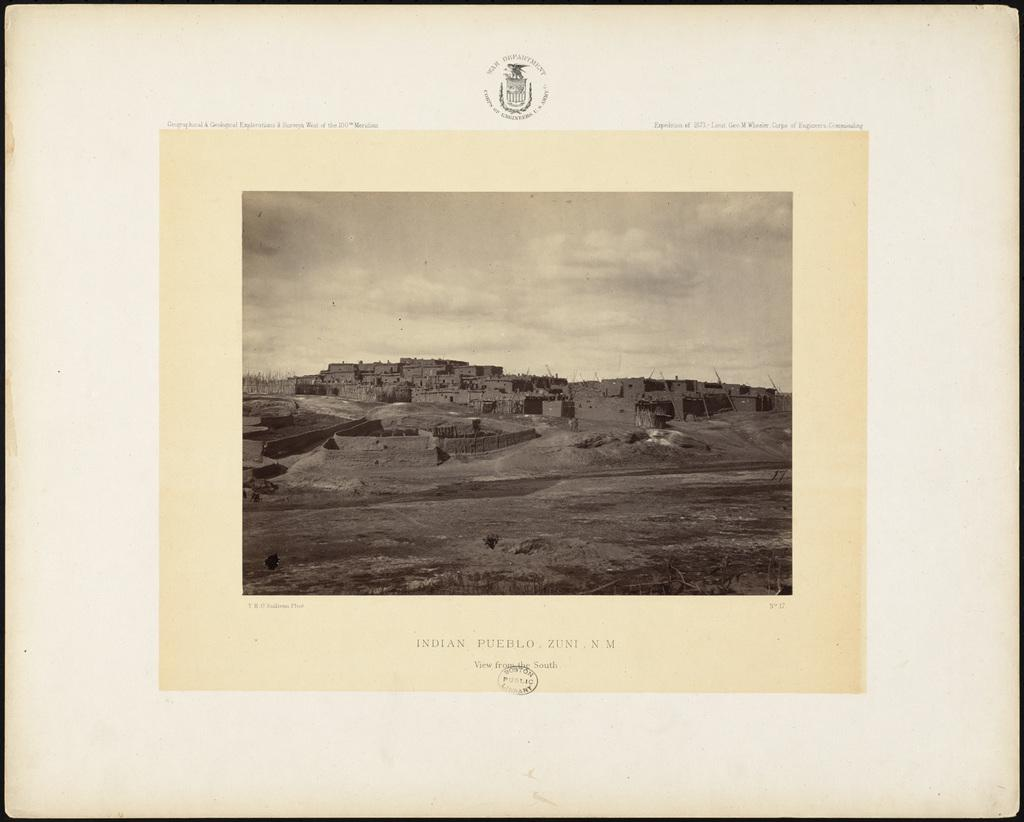<image>
Summarize the visual content of the image. a picture with the name Indian pueblo on it 